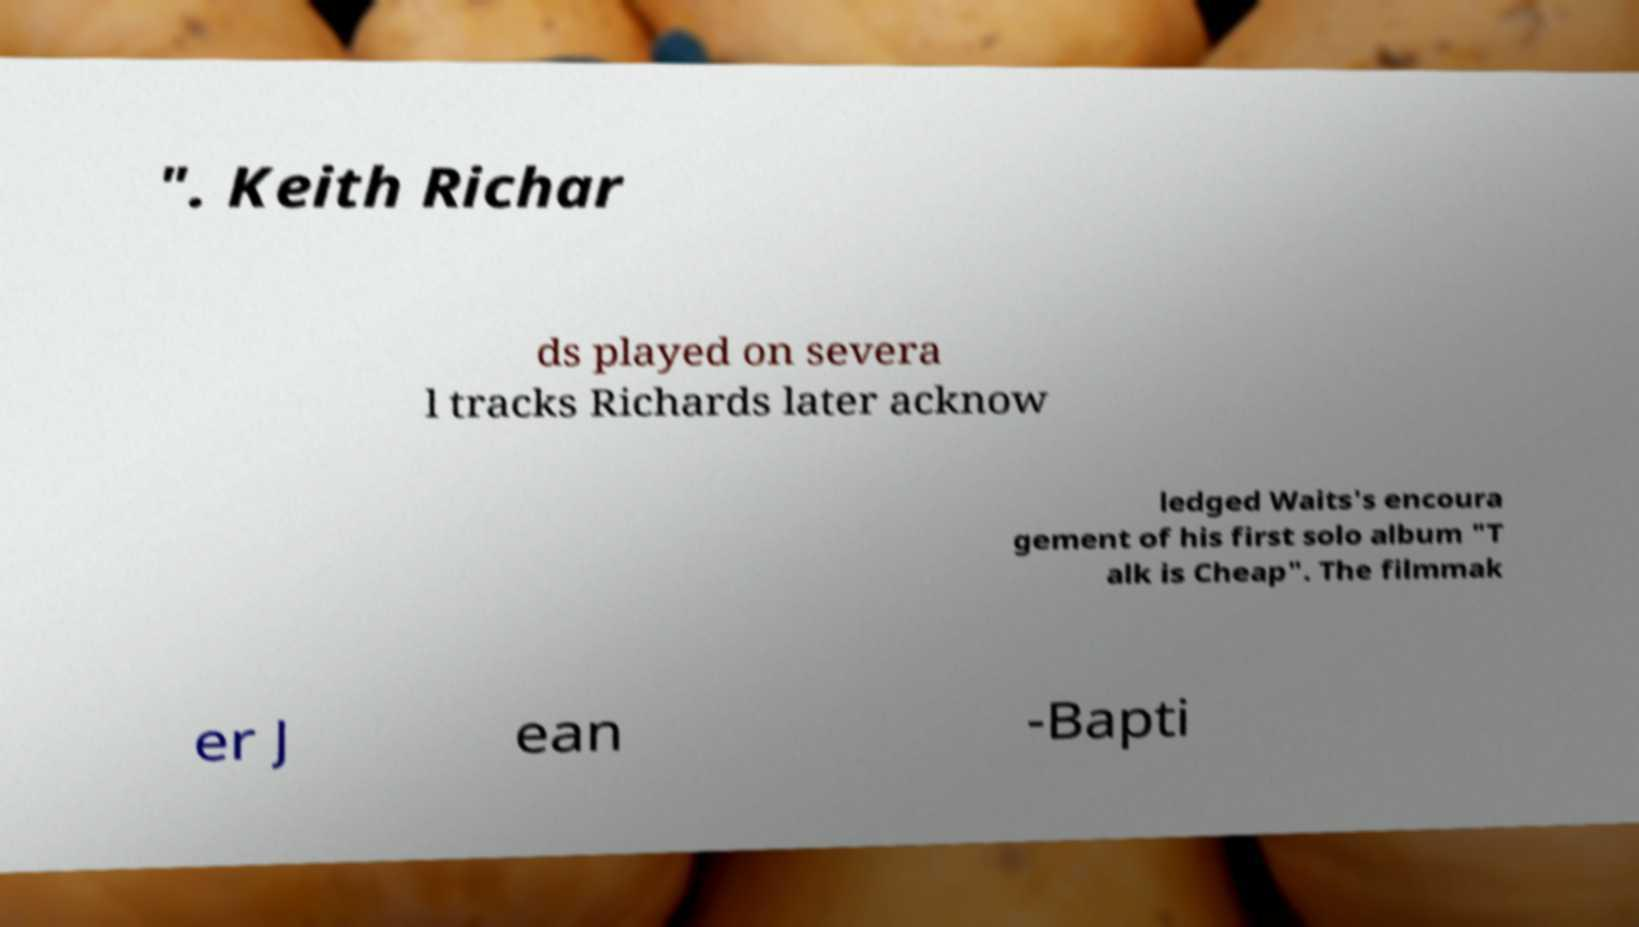Could you assist in decoding the text presented in this image and type it out clearly? ". Keith Richar ds played on severa l tracks Richards later acknow ledged Waits's encoura gement of his first solo album "T alk is Cheap". The filmmak er J ean -Bapti 